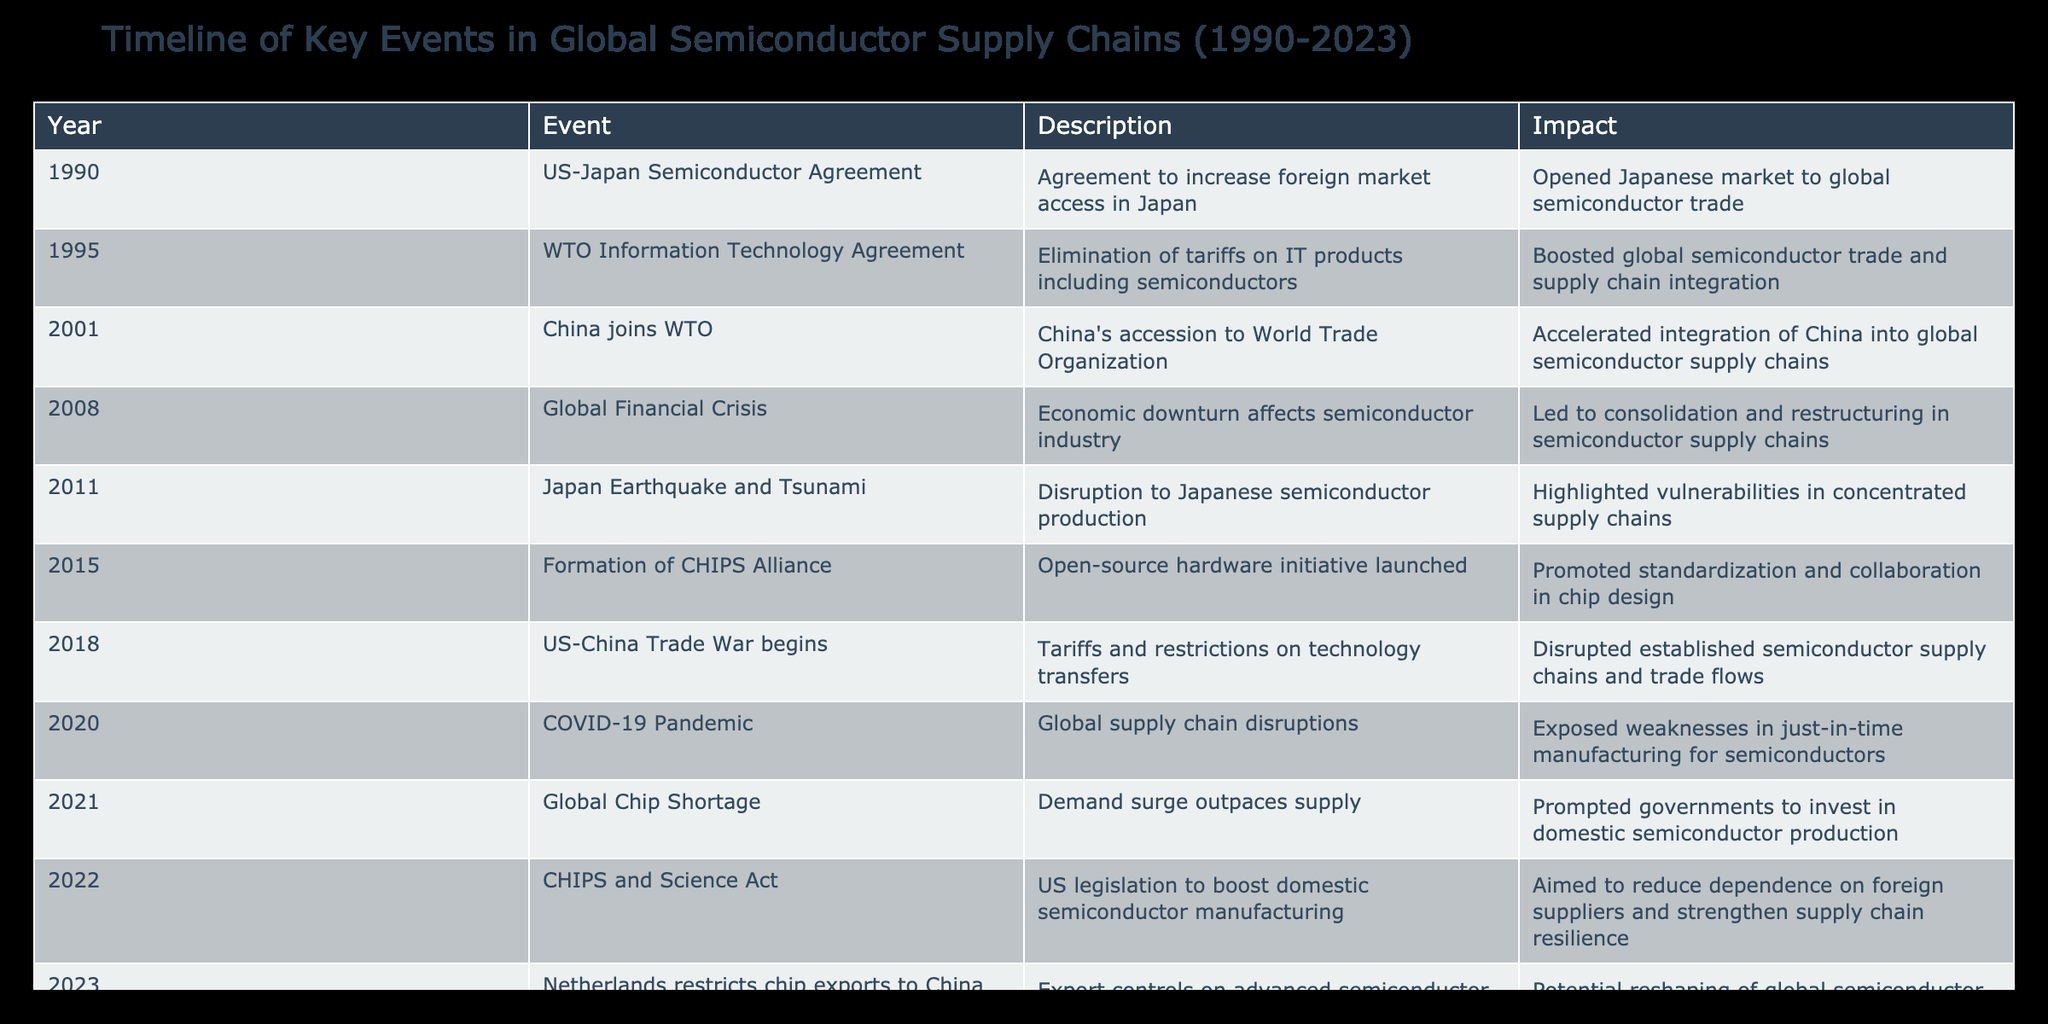What year did China join the WTO? The table indicates that China joined the WTO in the year 2001. This is explicitly stated in the "Year" column for the respective event.
Answer: 2001 What impact did the US-Japan Semiconductor Agreement have on global trade? The description in the table states that the US-Japan Semiconductor Agreement opened the Japanese market to global semiconductor trade. This indicates that the agreement had a positive impact on global trade by increasing access.
Answer: Opened Japanese market to global semiconductor trade Which event in the timeline had the most significant global impact on supply chain vulnerabilities? The Japan Earthquake and Tsunami event in 2011 highlighted vulnerabilities in concentrated supply chains. Compared to other events, this incident specifically indicated a significant disruption in the supply chain, differentiating it from other impacts.
Answer: Japan Earthquake and Tsunami How many years passed between the formation of the CHIPS Alliance and the CHIPS and Science Act? The formation of the CHIPS Alliance occurred in 2015, and the CHIPS and Science Act was enacted in 2022. Subtracting 2015 from 2022 gives us 7 years. This is a straightforward calculation of the difference between the two years.
Answer: 7 years Was the Global Financial Crisis in 2008 beneficial or detrimental to the semiconductor industry? According to the table, the Global Financial Crisis had a detrimental impact on the semiconductor industry, leading to consolidation and restructuring within semiconductor supply chains. This indicates that the event negatively affected the industry.
Answer: Detrimental 